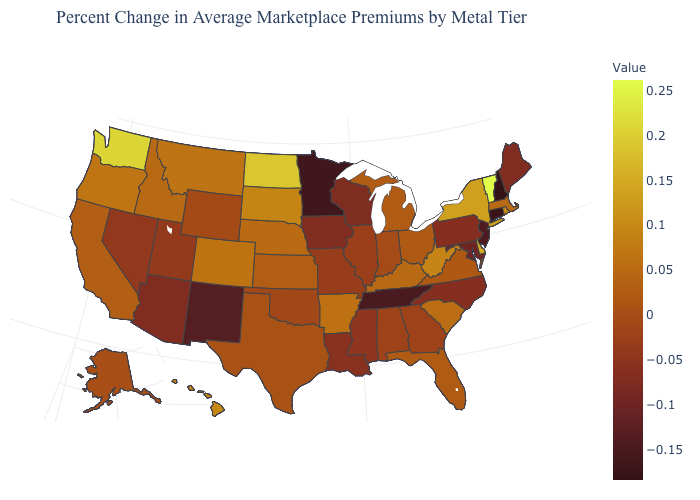Is the legend a continuous bar?
Give a very brief answer. Yes. Does Utah have a lower value than Massachusetts?
Write a very short answer. Yes. Does Vermont have the highest value in the USA?
Short answer required. Yes. Does Louisiana have a lower value than Kansas?
Give a very brief answer. Yes. Does North Dakota have the lowest value in the MidWest?
Be succinct. No. Is the legend a continuous bar?
Be succinct. Yes. Among the states that border North Dakota , does South Dakota have the lowest value?
Be succinct. No. Which states have the lowest value in the MidWest?
Keep it brief. Minnesota. 